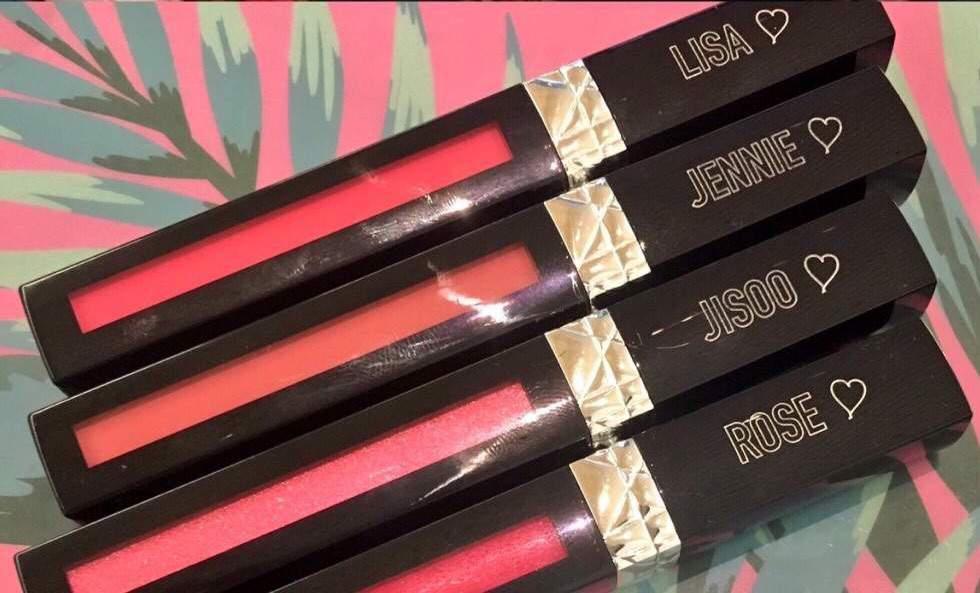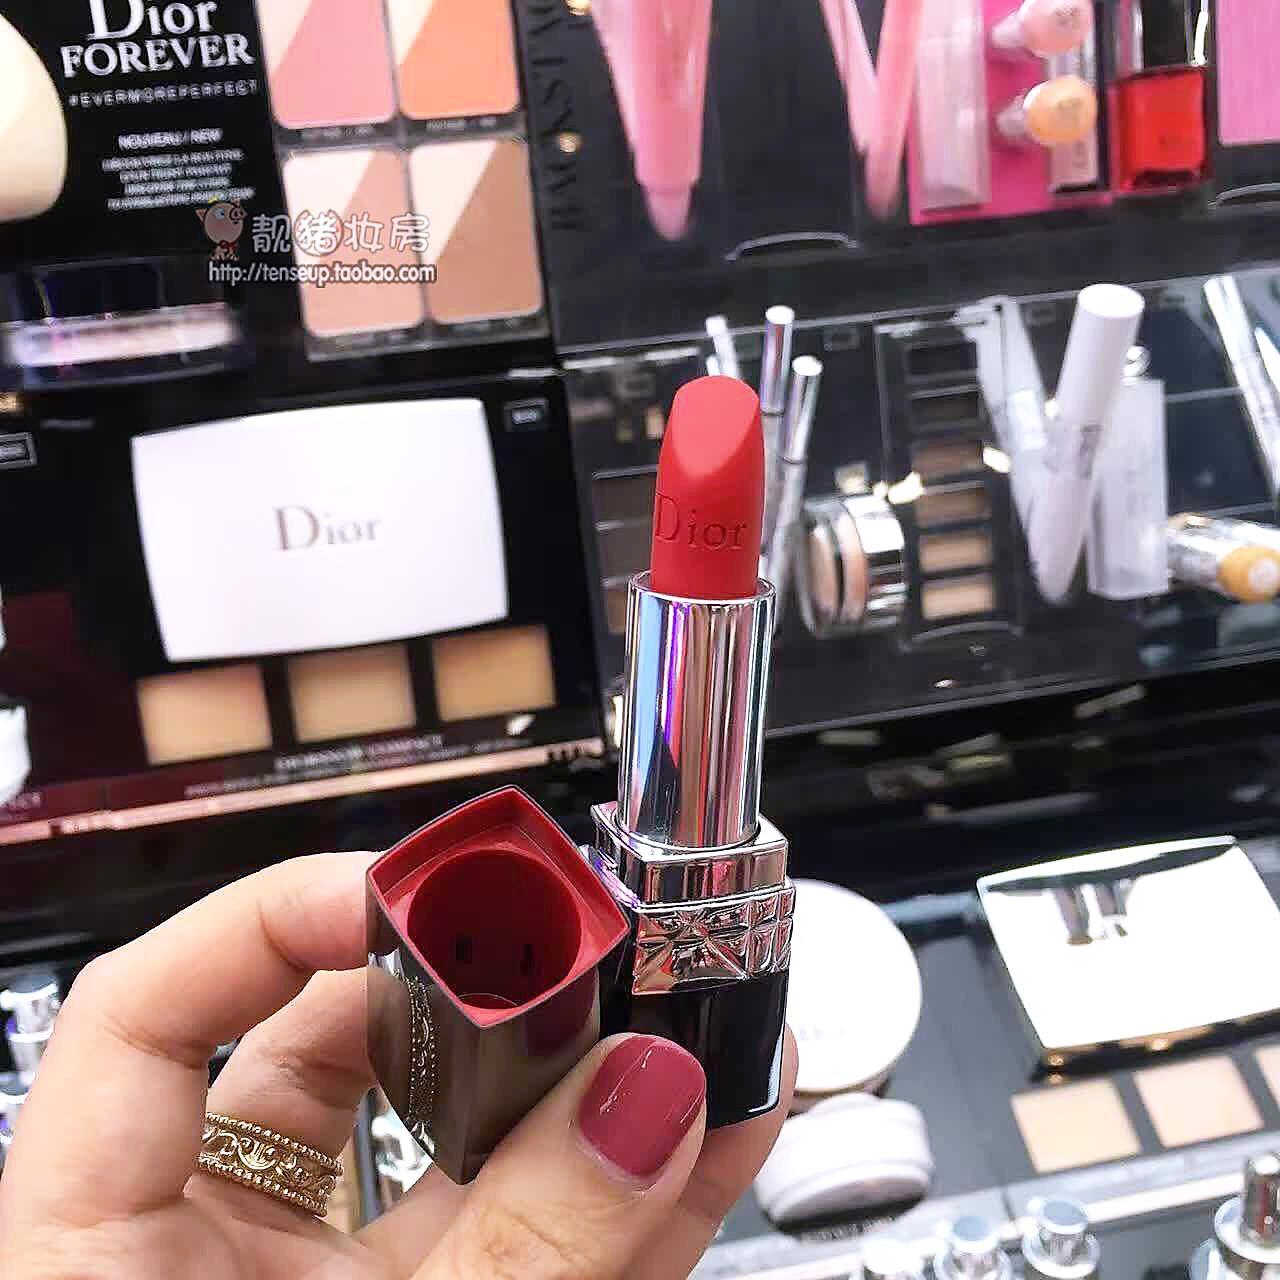The first image is the image on the left, the second image is the image on the right. Given the left and right images, does the statement "An image shows a hand holding an opened lipstick." hold true? Answer yes or no. Yes. The first image is the image on the left, the second image is the image on the right. Considering the images on both sides, is "A human hand is holding a lipstick without a cap." valid? Answer yes or no. Yes. 